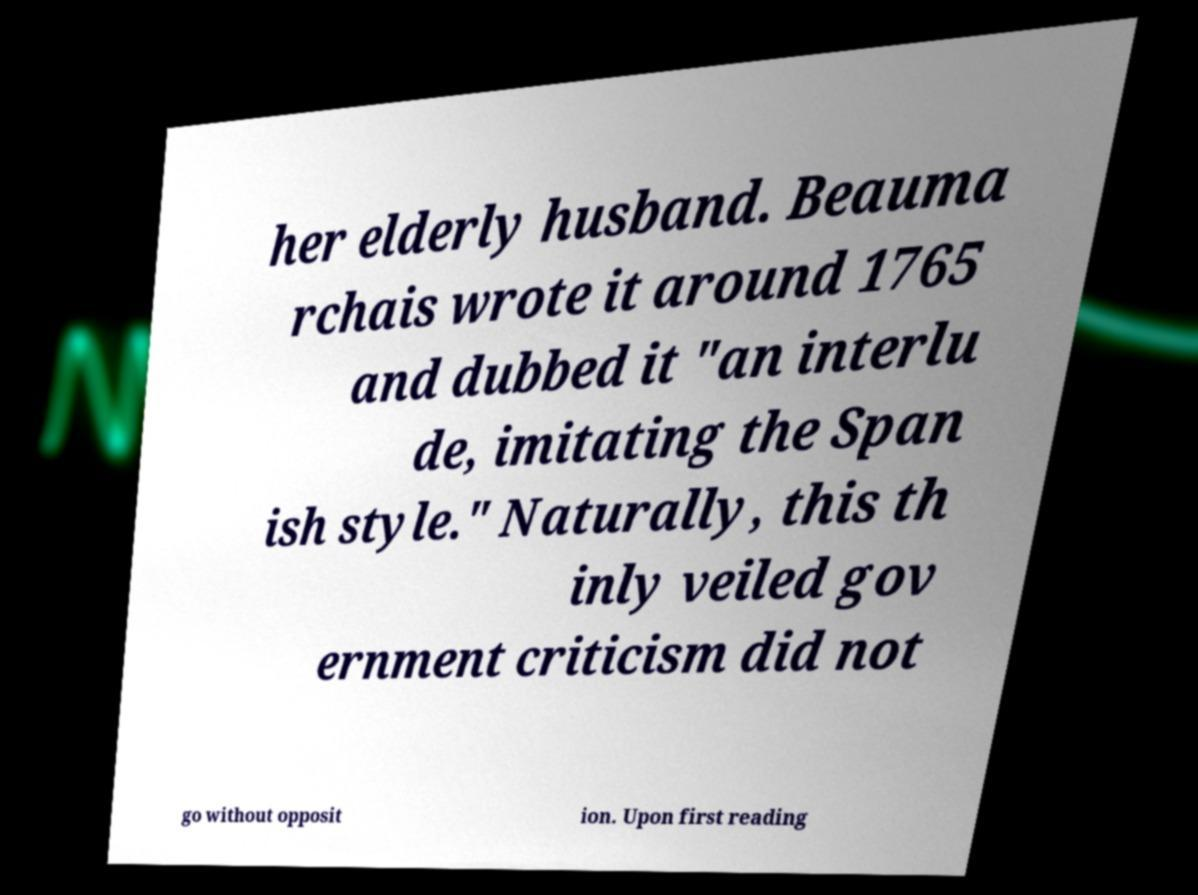Could you extract and type out the text from this image? her elderly husband. Beauma rchais wrote it around 1765 and dubbed it "an interlu de, imitating the Span ish style." Naturally, this th inly veiled gov ernment criticism did not go without opposit ion. Upon first reading 